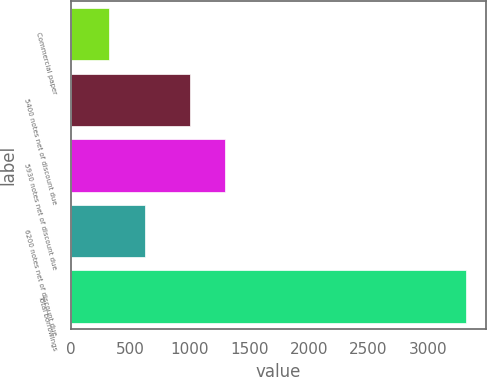Convert chart to OTSL. <chart><loc_0><loc_0><loc_500><loc_500><bar_chart><fcel>Commercial paper<fcel>5400 notes net of discount due<fcel>5930 notes net of discount due<fcel>6200 notes net of discount due<fcel>Total borrowings<nl><fcel>324.6<fcel>999<fcel>1298.89<fcel>624.49<fcel>3323.5<nl></chart> 